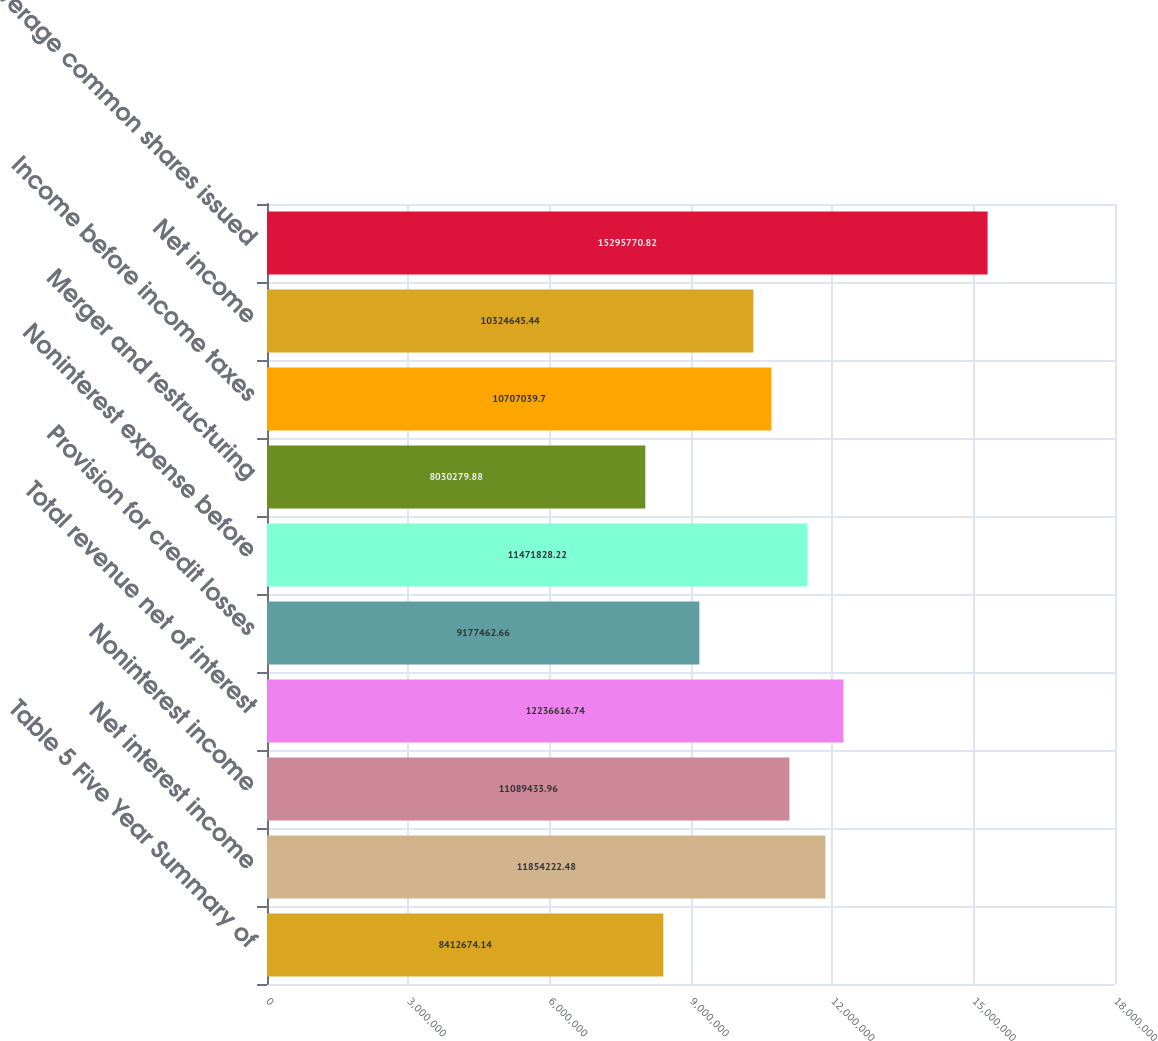Convert chart. <chart><loc_0><loc_0><loc_500><loc_500><bar_chart><fcel>Table 5 Five Year Summary of<fcel>Net interest income<fcel>Noninterest income<fcel>Total revenue net of interest<fcel>Provision for credit losses<fcel>Noninterest expense before<fcel>Merger and restructuring<fcel>Income before income taxes<fcel>Net income<fcel>Average common shares issued<nl><fcel>8.41267e+06<fcel>1.18542e+07<fcel>1.10894e+07<fcel>1.22366e+07<fcel>9.17746e+06<fcel>1.14718e+07<fcel>8.03028e+06<fcel>1.0707e+07<fcel>1.03246e+07<fcel>1.52958e+07<nl></chart> 